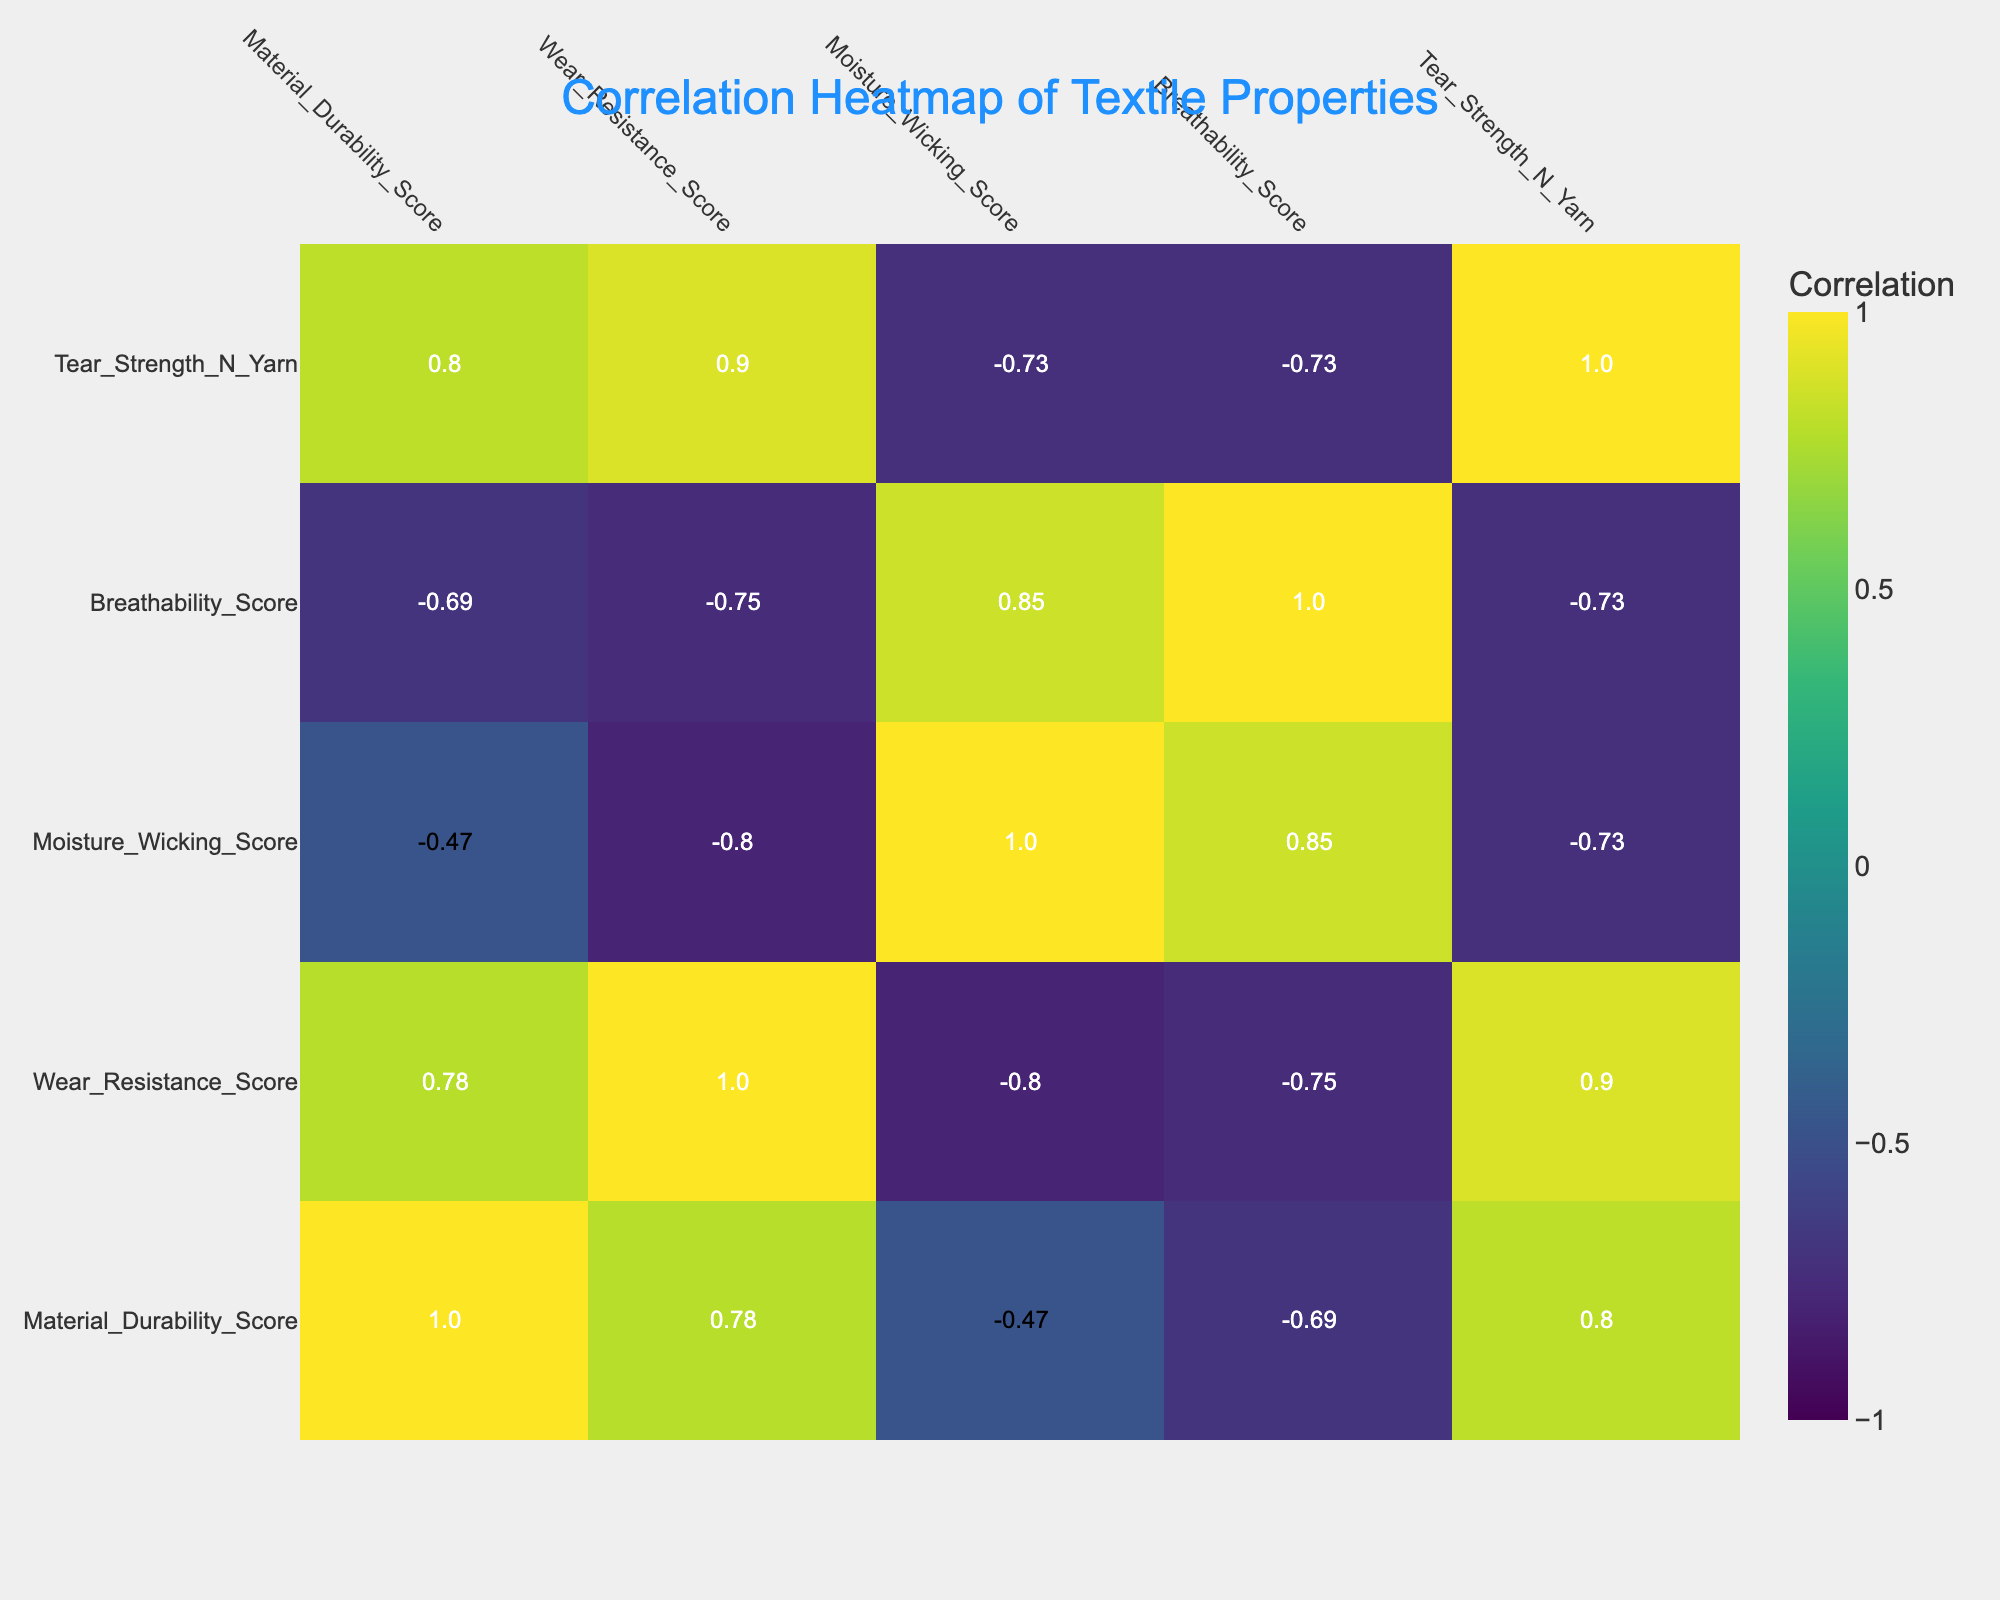What is the highest material durability score among the textiles listed? The textile type with the highest material durability score can be found in the correlation table. By comparing the scores, we see that Aramid has a score of 95, which is higher than all other textile types.
Answer: 95 Which textile type has the lowest wear resistance score? By looking at the wear resistance scores in the table, we see that Rayon has the lowest score of 60.
Answer: Rayon Is there a positive correlation between material durability and wear resistance scores? To determine the correlation, we check the correlation coefficient between the two scores in the table. A coefficient value greater than 0 indicates a positive correlation. The correlation score between material durability and wear resistance is positive.
Answer: Yes What is the average breathability score of all textiles? To find the average, add all the breathability scores together: 85 + 70 + 65 + 90 + 75 + 80 + 55 + 70 + 80 + 88 = 785. Divide by the number of textile types, which is 10. So, the average is 785/10 = 78.5.
Answer: 78.5 If we exclude the highest and the lowest material durability scores, what would be the average of the remaining textile types? The highest score is 95 (Aramid) and the lowest is 65 (Rayon). By excluding these, we sum the remaining durability scores: 75 + 85 + 90 + 80 + 70 + 78 + 80 + 72 = 570. There are 8 remaining textile types, so we calculate the average by dividing the total sum by 8, which gives 570/8 = 71.25.
Answer: 71.25 Which textile has the best moisture-wicking score and what is its value? By reviewing the moisture-wicking scores, we identify that Spandex has the highest score of 90 compared to the other textile types.
Answer: Spandex, 90 Is the tear strength of Cotton higher than that of Wool? We compare the tear strength scores of Cotton (25) and Wool (20). Since 25 is greater than 20, Cotton does have a higher tear strength.
Answer: Yes Which two textile types have the most similar moisture-wicking scores, and what are their values? Upon reviewing the moisture-wicking scores, we find that both Wool (85) and Linen (85) have identical scores, showing that they are the textile types with the most similar moisture-wicking values.
Answer: Wool and Linen, 85 